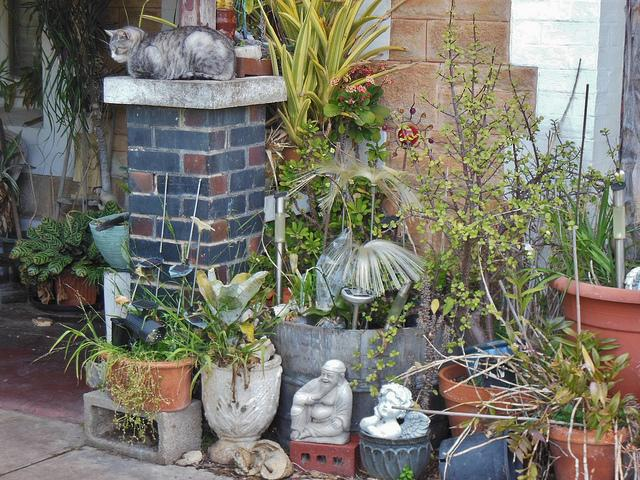What is the little angel in the flower pot called? cherub 